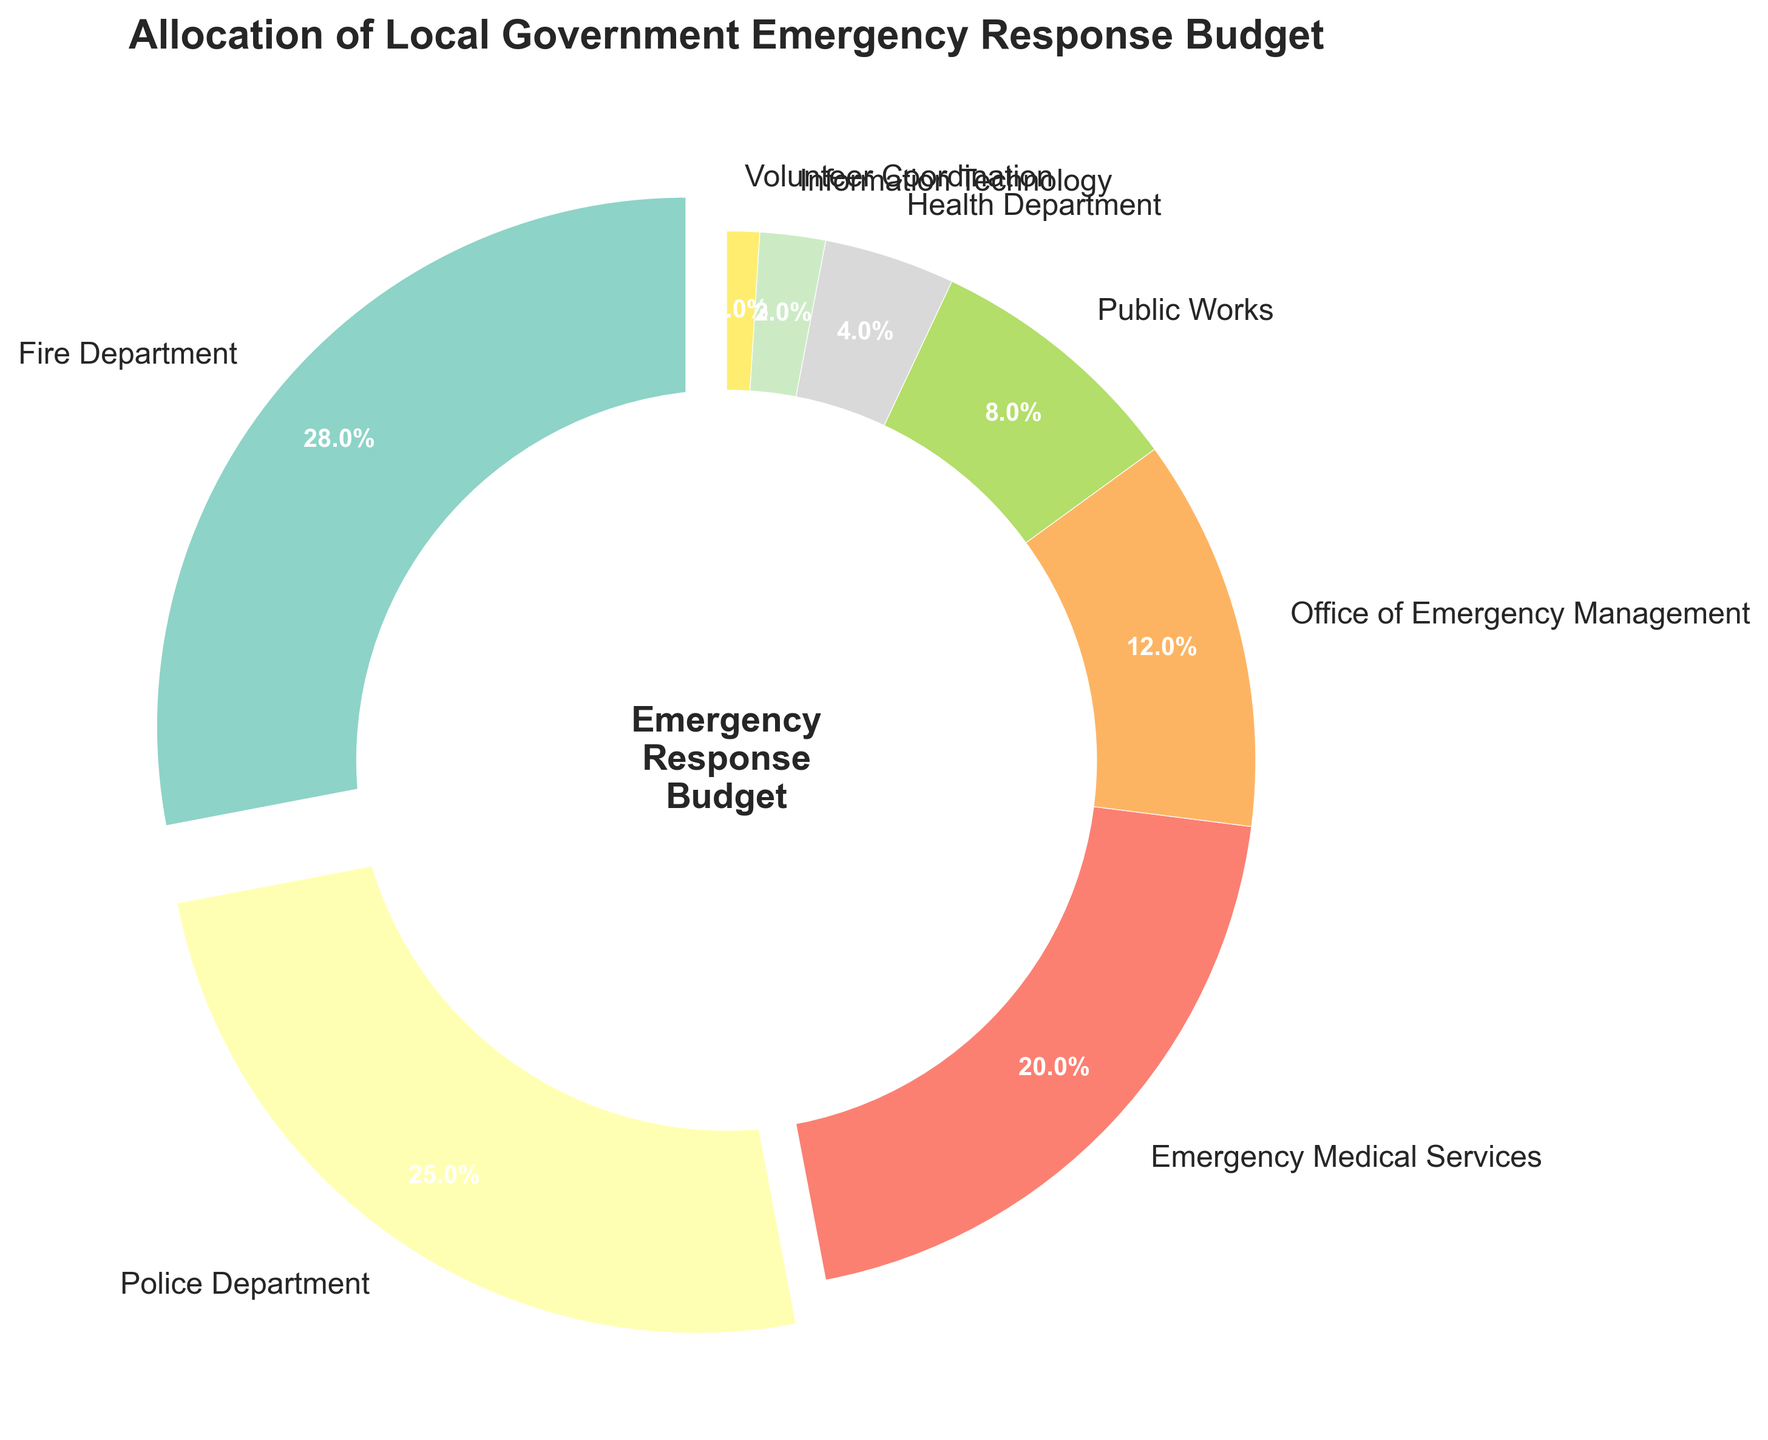Which department receives the highest budget allocation? The Fire Department receives the highest budget allocation, as indicated by the largest percentage slice at 28%.
Answer: Fire Department Which two departments together receive the most budget? The Fire Department and Police Department collectively receive the most budget, combining 28% and 25% respectively, totaling 53%.
Answer: Fire Department and Police Department How much more budget is allocated to the Police Department compared to the Health Department? The Police Department receives 25%, while the Health Department receives 4%. The difference is 25% - 4% = 21%.
Answer: 21% What is the total budget allocation for the Office of Emergency Management, Public Works, and Health Department combined? The Office of Emergency Management has 12%, Public Works has 8%, and the Health Department has 4%. The combined total is 12% + 8% + 4% = 24%.
Answer: 24% Is the budget allocation for Emergency Medical Services more than the combined allocation for Information Technology and Volunteer Coordination? Emergency Medical Services receives 20%. Information Technology and Volunteer Coordination together receive 2% + 1% = 3%. Thus, 20% > 3%.
Answer: Yes Which department receives the smallest budget allocation and what is that percentage? The Volunteer Coordination department receives the smallest allocation with 1%.
Answer: Volunteer Coordination, 1% How much more budget allocation does the Fire Department receive compared to Emergency Medical Services? The Fire Department receives 28%, while Emergency Medical Services receives 20%. The difference is 28% - 20% = 8%.
Answer: 8% What is the average budget allocation for Public Works, Health Department, and Information Technology? These departments receive 8%, 4%, and 2% respectively. The average is (8% + 4% + 2%) / 3 = 14% / 3 ≈ 4.67%.
Answer: 4.67% Are there any departments with the same budget allocation? By examining each slice, no two departments have the same budget allocation percentage.
Answer: No What percentage of the budget is allocated to departments other than the Fire Department, Police Department, and Emergency Medical Services? The combined total for Fire Department, Police Department, and Emergency Medical Services is 28% + 25% + 20% = 73%. Therefore, the remaining is 100% - 73% = 27%.
Answer: 27% 